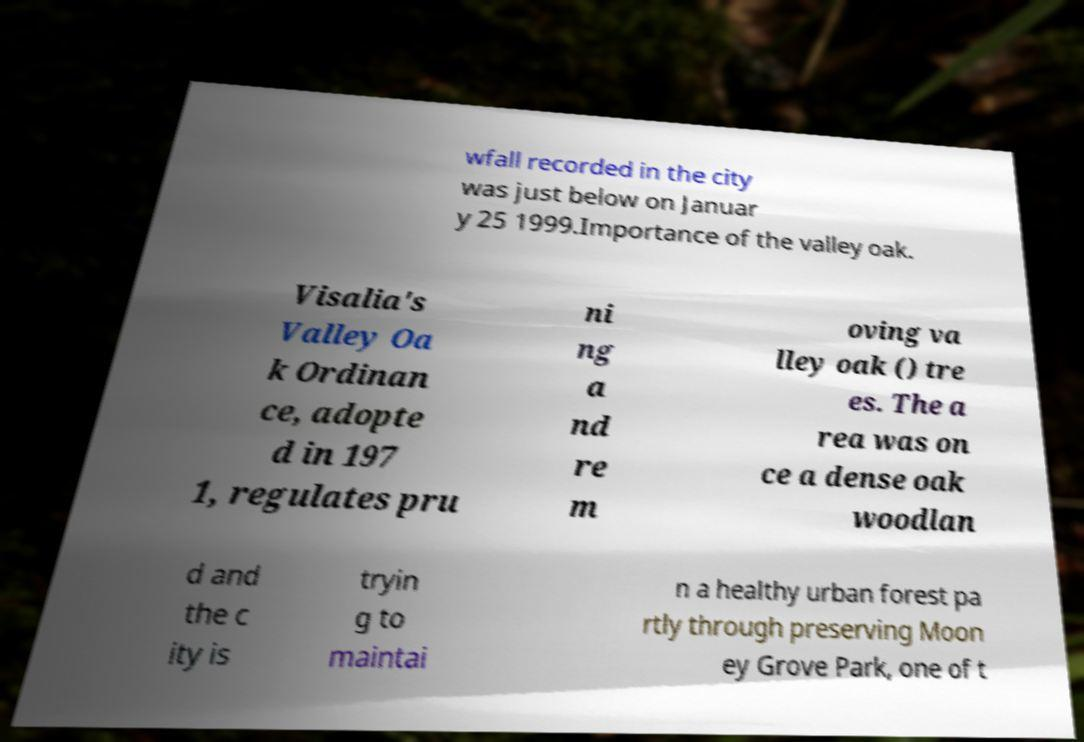There's text embedded in this image that I need extracted. Can you transcribe it verbatim? wfall recorded in the city was just below on Januar y 25 1999.Importance of the valley oak. Visalia's Valley Oa k Ordinan ce, adopte d in 197 1, regulates pru ni ng a nd re m oving va lley oak () tre es. The a rea was on ce a dense oak woodlan d and the c ity is tryin g to maintai n a healthy urban forest pa rtly through preserving Moon ey Grove Park, one of t 